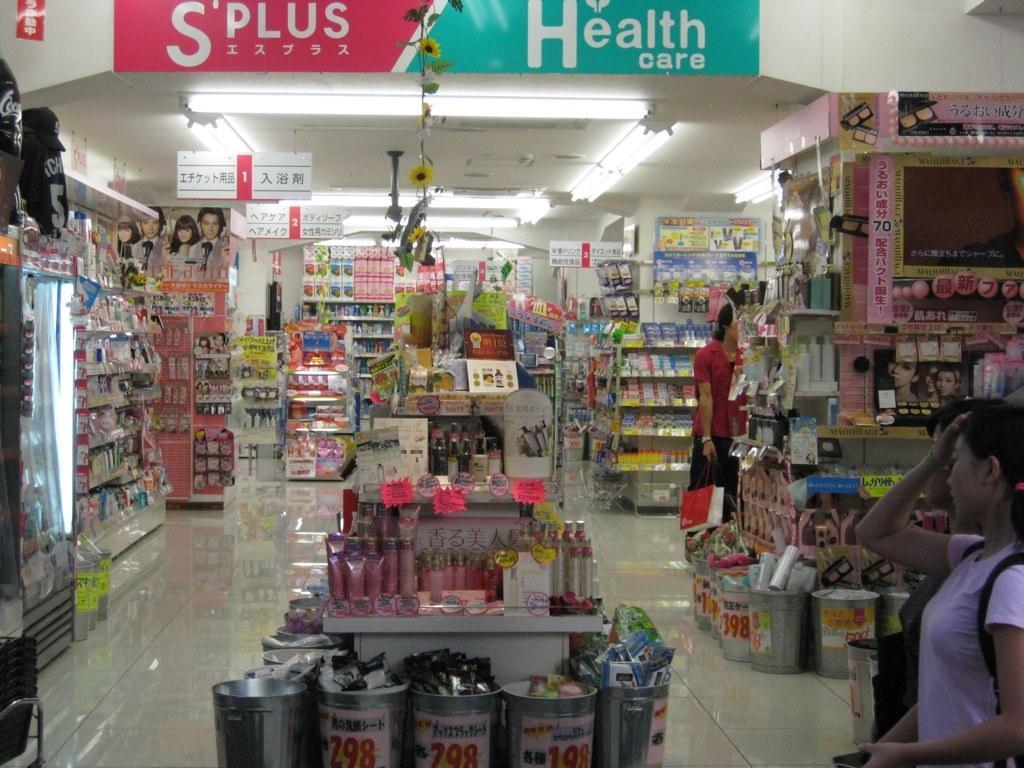Please provide a concise description of this image. In this picture I can observe a store. On the right side there are some people. I can observe some accessories placed in the racks. 